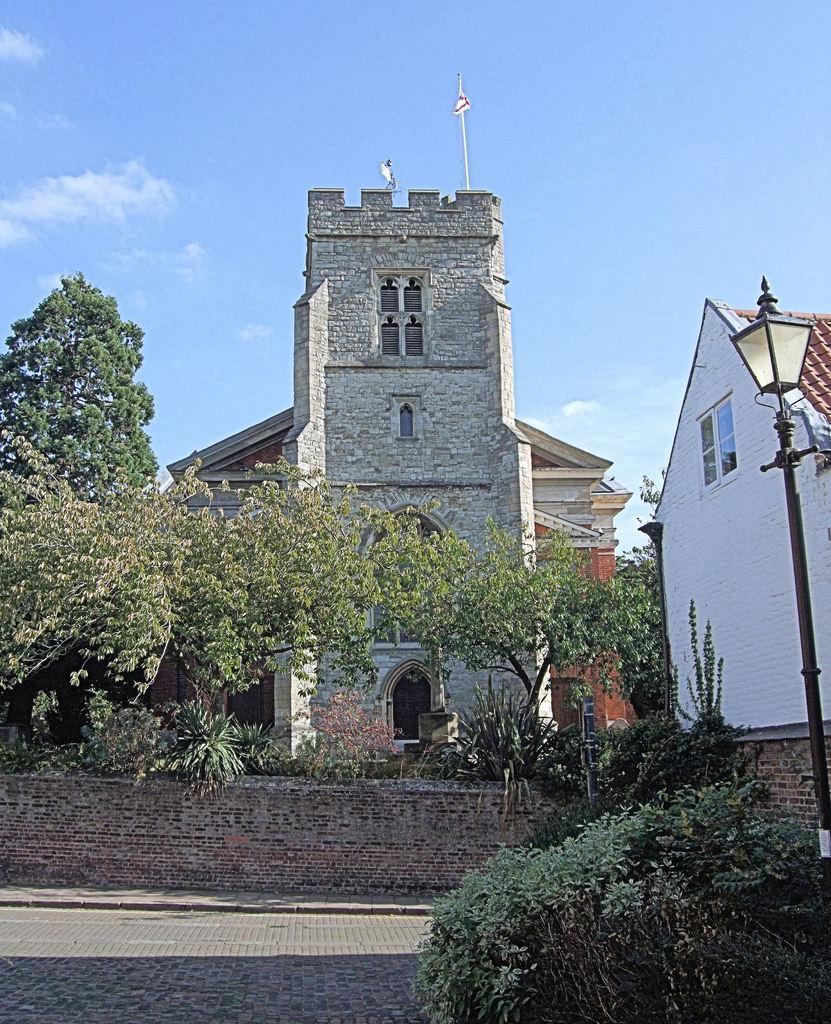Describe this image in one or two sentences. In this image there is wall beside the pavement. Behind the wall there are few plants and trees. Behind it there are buildings. Right side there is a street light. Before it there are few plants. Bottom of image there is a cobblestone path. Top of image there is sky. 